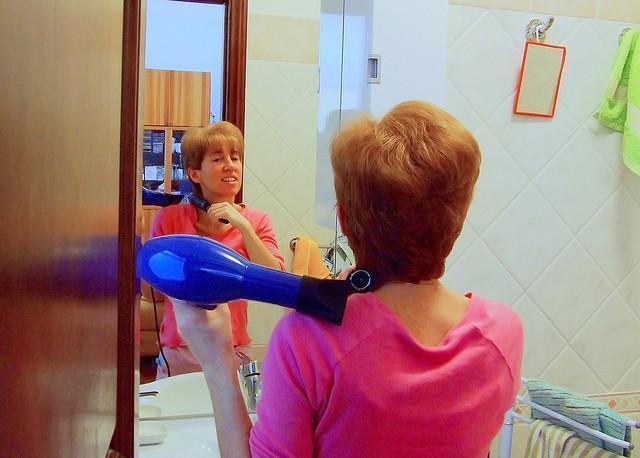What is she doing?
Indicate the correct response and explain using: 'Answer: answer
Rationale: rationale.'
Options: Fixing hair, cleaning neck, hiding shirt, heating head. Answer: fixing hair.
Rationale: She is using a dryer and brush to style. 